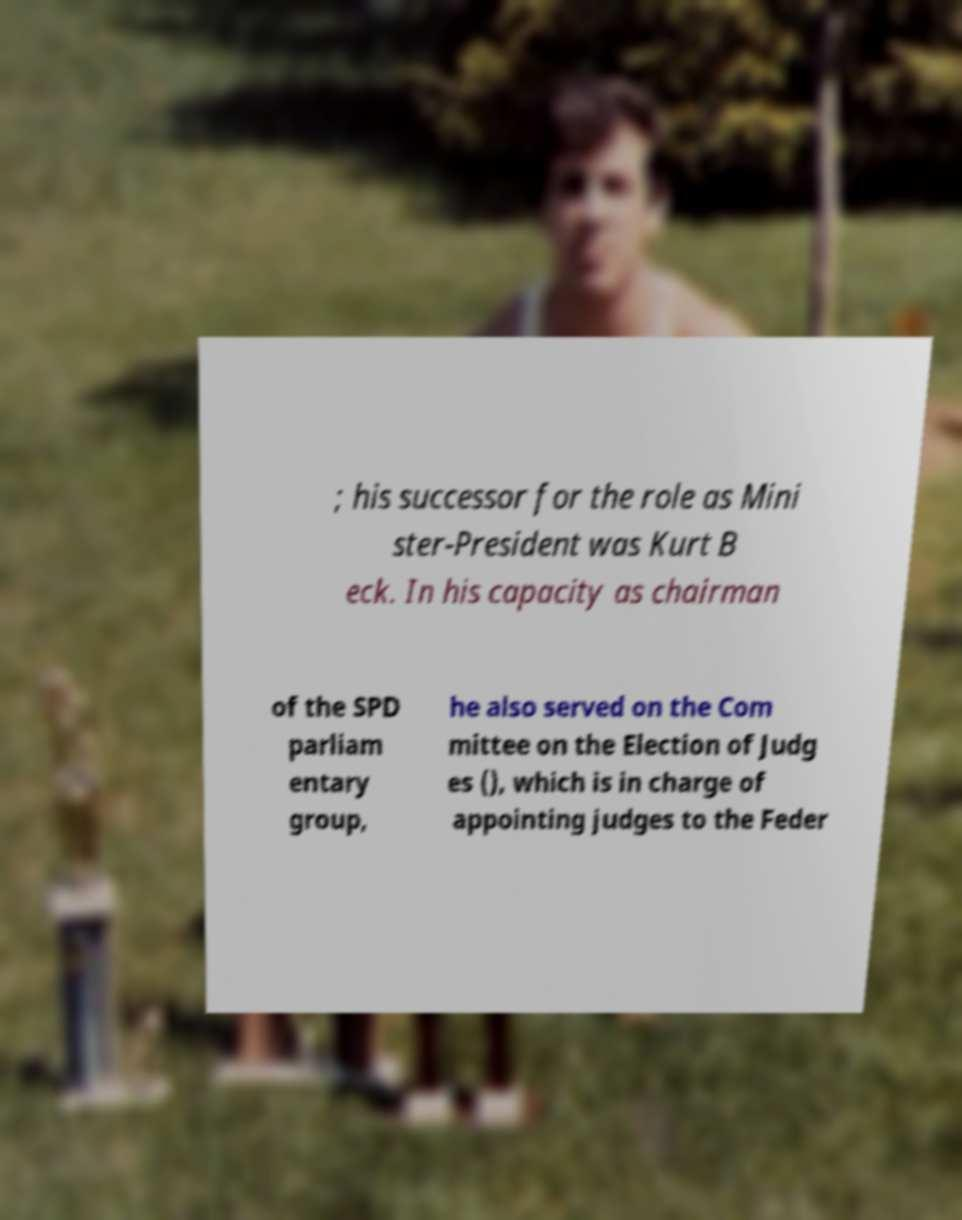There's text embedded in this image that I need extracted. Can you transcribe it verbatim? ; his successor for the role as Mini ster-President was Kurt B eck. In his capacity as chairman of the SPD parliam entary group, he also served on the Com mittee on the Election of Judg es (), which is in charge of appointing judges to the Feder 